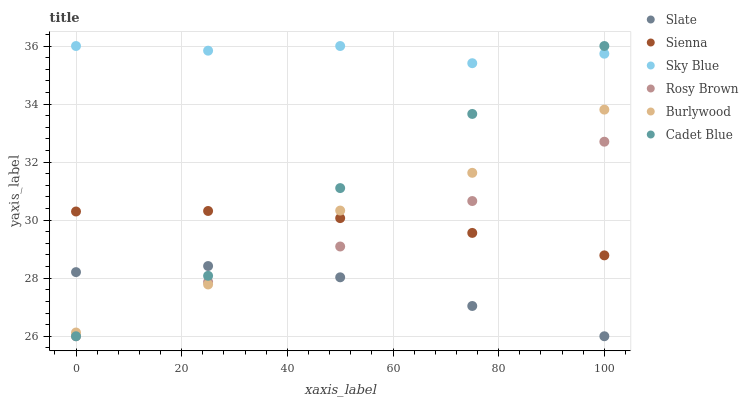Does Slate have the minimum area under the curve?
Answer yes or no. Yes. Does Sky Blue have the maximum area under the curve?
Answer yes or no. Yes. Does Burlywood have the minimum area under the curve?
Answer yes or no. No. Does Burlywood have the maximum area under the curve?
Answer yes or no. No. Is Sienna the smoothest?
Answer yes or no. Yes. Is Burlywood the roughest?
Answer yes or no. Yes. Is Slate the smoothest?
Answer yes or no. No. Is Slate the roughest?
Answer yes or no. No. Does Cadet Blue have the lowest value?
Answer yes or no. Yes. Does Burlywood have the lowest value?
Answer yes or no. No. Does Sky Blue have the highest value?
Answer yes or no. Yes. Does Burlywood have the highest value?
Answer yes or no. No. Is Slate less than Sienna?
Answer yes or no. Yes. Is Sky Blue greater than Rosy Brown?
Answer yes or no. Yes. Does Slate intersect Rosy Brown?
Answer yes or no. Yes. Is Slate less than Rosy Brown?
Answer yes or no. No. Is Slate greater than Rosy Brown?
Answer yes or no. No. Does Slate intersect Sienna?
Answer yes or no. No. 